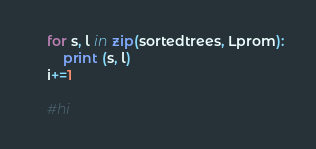<code> <loc_0><loc_0><loc_500><loc_500><_Python_>
	for s, l in zip(sortedtrees, Lprom):
		print (s, l)
	i+=1

	#hi
</code> 